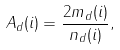Convert formula to latex. <formula><loc_0><loc_0><loc_500><loc_500>A _ { d } ( i ) = \frac { 2 m _ { d } ( i ) } { n _ { d } ( i ) } ,</formula> 